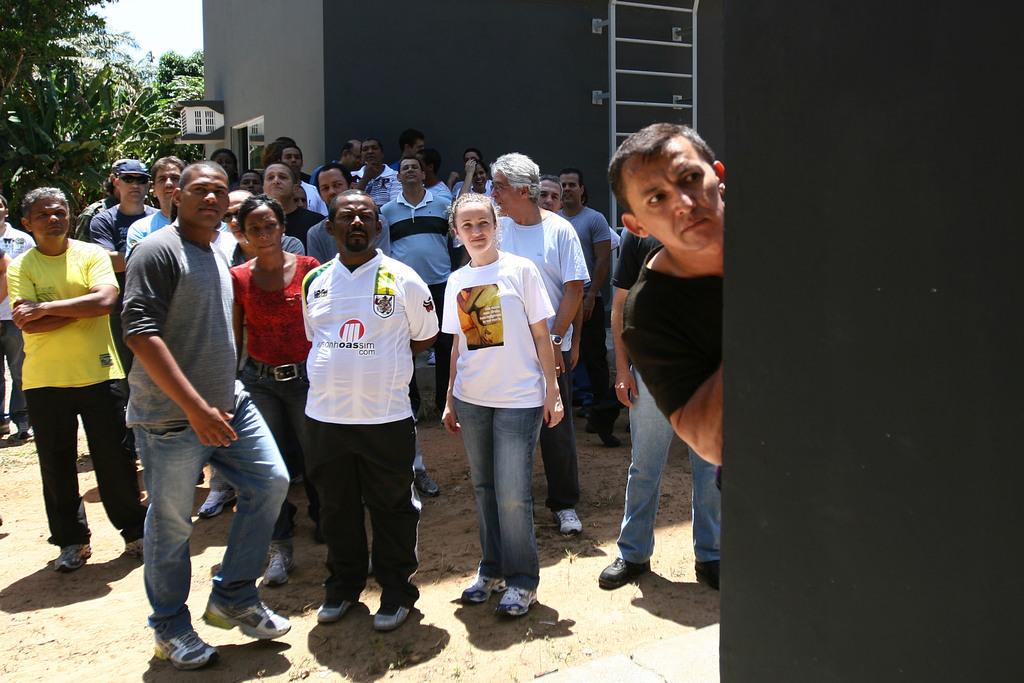How many people are in the image? There is a group of people in the image, but the exact number is not specified. Where are the people standing in the image? The people are standing on the grass in the image. What can be seen in the background of the image? There is a building and trees in the background of the image. What type of apparel is the peace symbol wearing in the image? There is no peace symbol or apparel present in the image; it features a group of people standing on the grass with a building and trees in the background. 